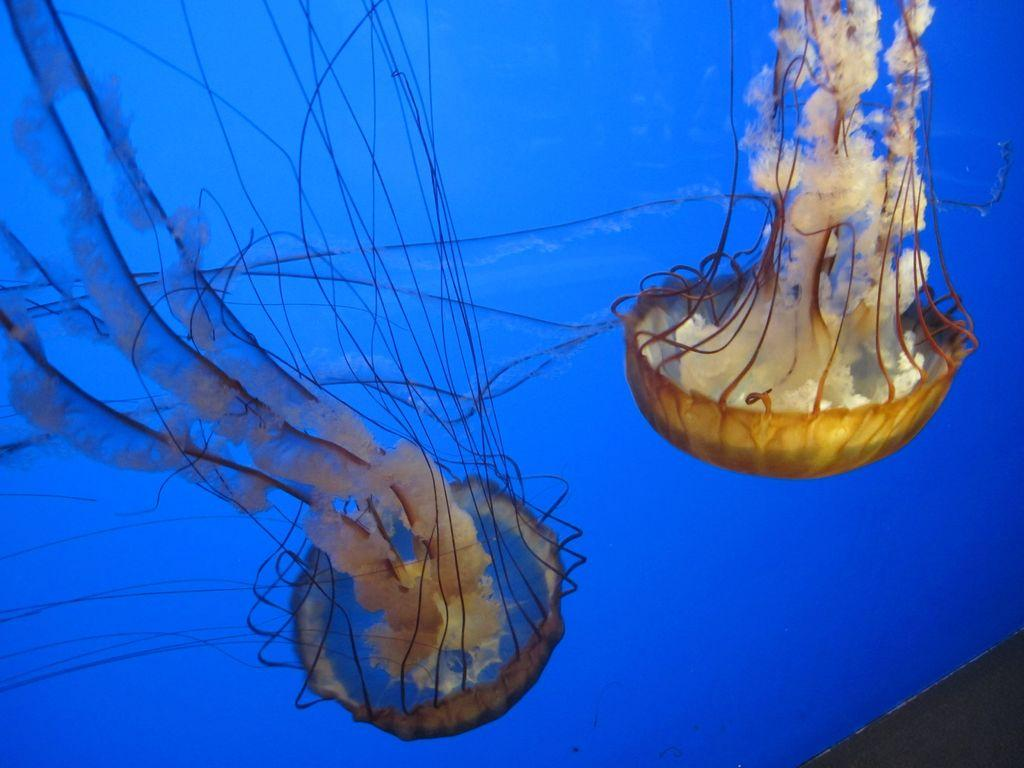What creatures are present in the image? There are two jellyfishes in the image. Where are the jellyfishes located? The jellyfishes are in the water. What type of coal is being used by the jellyfishes in the image? There is no coal present in the image, as it features jellyfishes in the water. What type of trousers are the jellyfishes wearing in the image? Jellyfishes do not wear trousers, as they are marine creatures without limbs or clothing. 